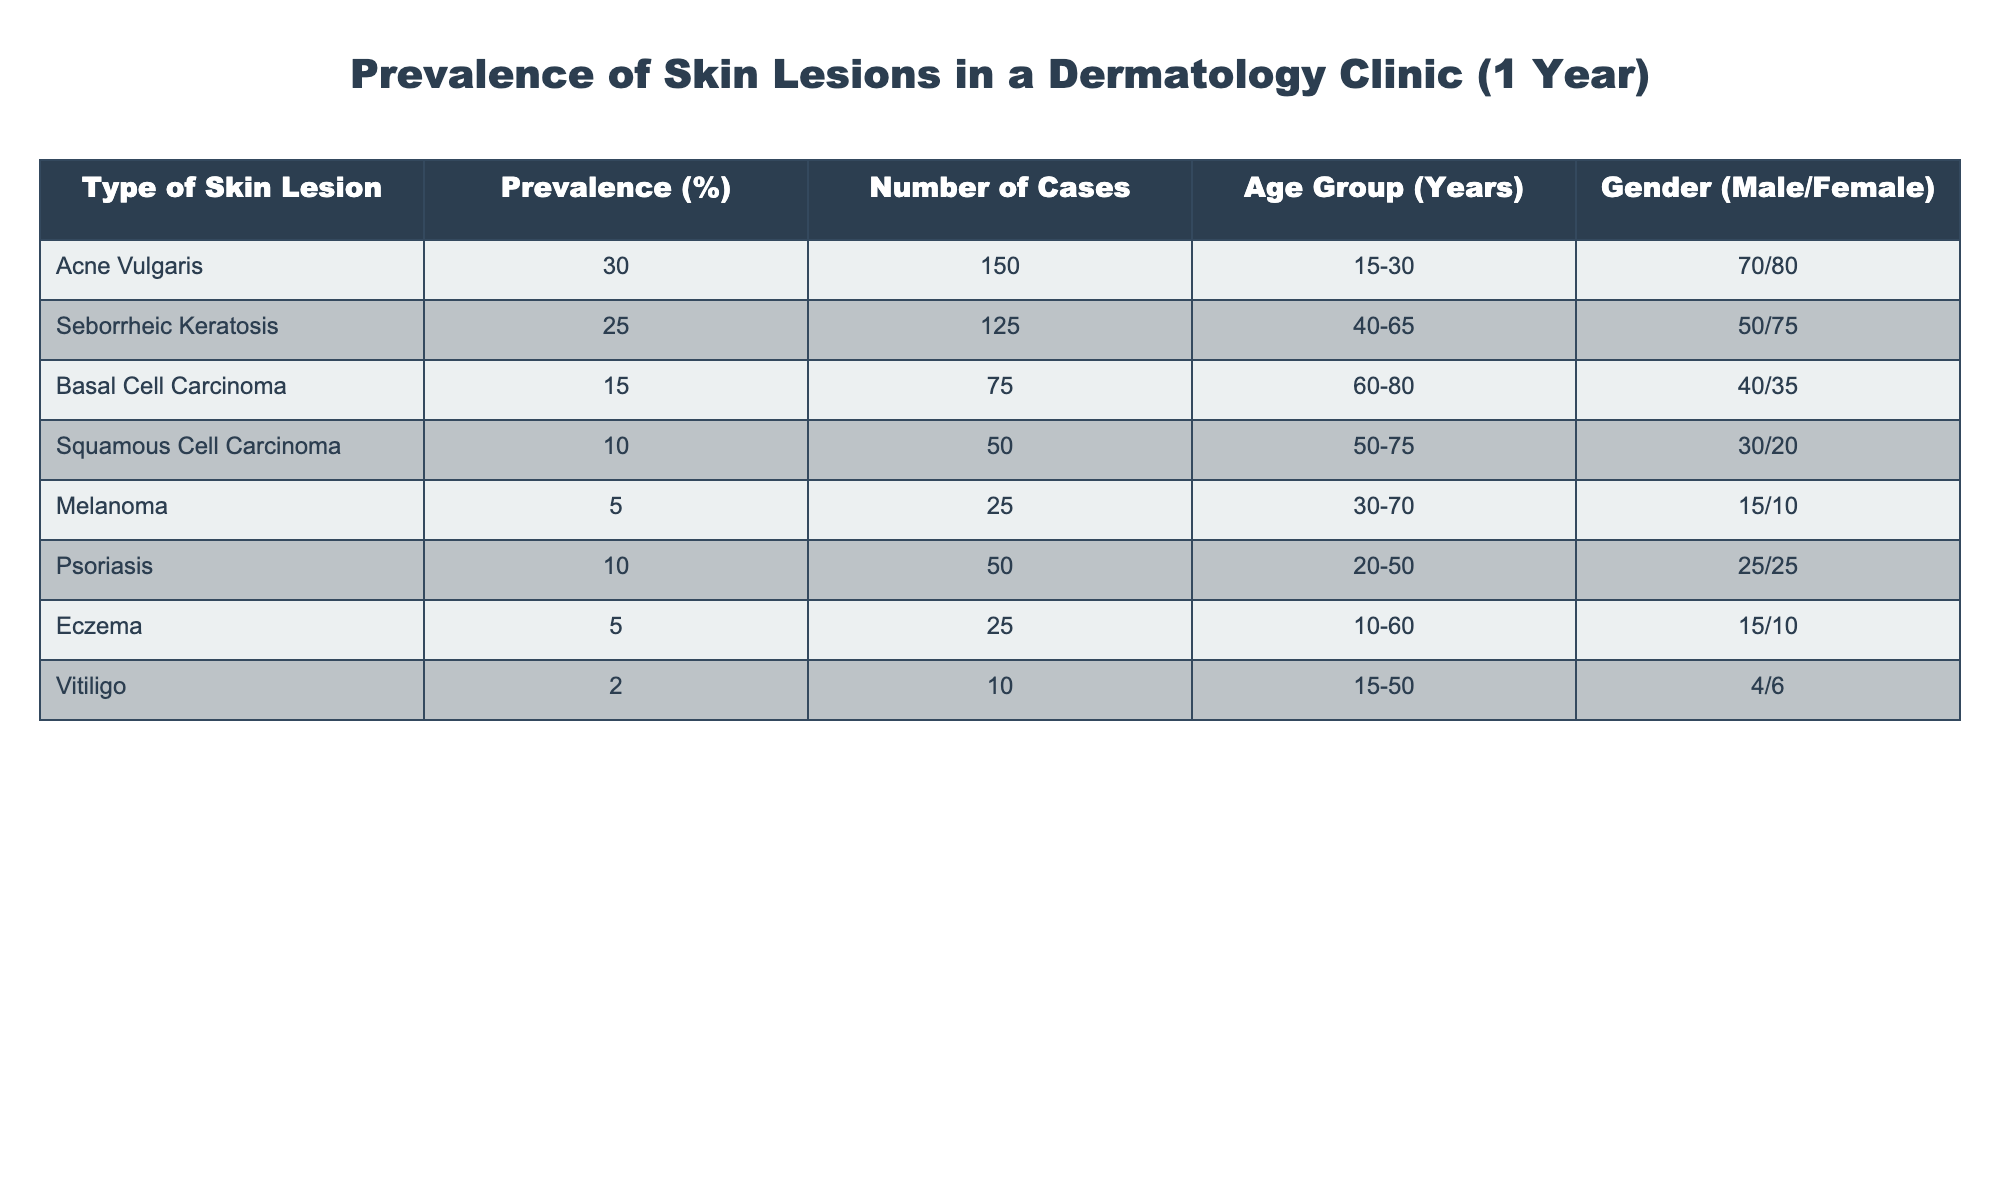What is the most prevalent type of skin lesion in the clinic? The table shows that Acne Vulgaris has the highest prevalence at 30%, which is listed in the first row of the data.
Answer: Acne Vulgaris How many cases of Basal Cell Carcinoma were recorded? Referring to the table, Basal Cell Carcinoma has a number of cases listed as 75.
Answer: 75 What is the total number of cases for Eczema and Psoriasis combined? Eczema has 25 cases and Psoriasis has 50 cases. Adding these together gives 25 + 50 = 75.
Answer: 75 Is the prevalence of Melanoma greater than that of Vitiligo? The prevalence of Melanoma is 5%, while Vitiligo has a prevalence of 2%. Since 5% is greater than 2%, the answer is yes.
Answer: Yes What is the average prevalence of skin lesions for all types combined? To calculate the average prevalence, sum all the prevalence percentages: 30 + 25 + 15 + 10 + 5 + 10 + 5 + 2 = 102. There are 8 types, so the average is 102 / 8 = 12.75.
Answer: 12.75 Which age group has the highest representation of cases for Squamous Cell Carcinoma? Squamous Cell Carcinoma cases fall within the 50-75 years age group, as indicated in the age group column.
Answer: 50-75 years Are there more male or female patients with Seborrheic Keratosis? The table shows there are 50 males and 75 females diagnosed with Seborrheic Keratosis. Since 75 is greater than 50, the answer is female.
Answer: Female What percentage of cases in the clinic does Psoriasis account for? The prevalence of Psoriasis is given as 10%. To find the percentage of total cases, divide 50 (Psoriasis cases) by 500 (total cases) and multiply by 100.
Answer: 10% 